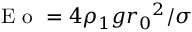Convert formula to latex. <formula><loc_0><loc_0><loc_500><loc_500>E o = 4 \rho _ { 1 } g { r _ { 0 } } ^ { 2 } / \sigma</formula> 